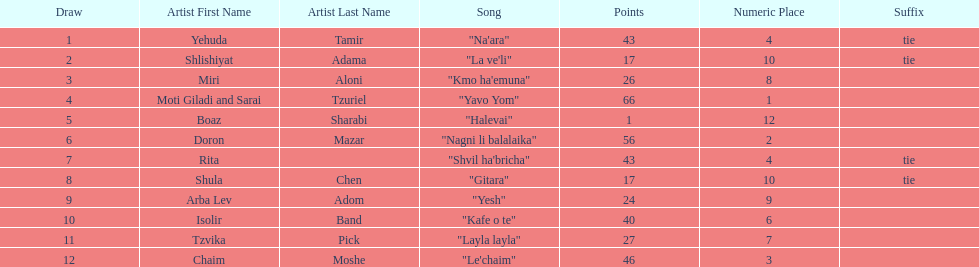What song earned the most points? "Yavo Yom". Could you parse the entire table as a dict? {'header': ['Draw', 'Artist First Name', 'Artist Last Name', 'Song', 'Points', 'Numeric Place', 'Suffix'], 'rows': [['1', 'Yehuda', 'Tamir', '"Na\'ara"', '43', '4', 'tie'], ['2', 'Shlishiyat', 'Adama', '"La ve\'li"', '17', '10', 'tie'], ['3', 'Miri', 'Aloni', '"Kmo ha\'emuna"', '26', '8', ''], ['4', 'Moti Giladi and Sarai', 'Tzuriel', '"Yavo Yom"', '66', '1', ''], ['5', 'Boaz', 'Sharabi', '"Halevai"', '1', '12', ''], ['6', 'Doron', 'Mazar', '"Nagni li balalaika"', '56', '2', ''], ['7', 'Rita', '', '"Shvil ha\'bricha"', '43', '4', 'tie'], ['8', 'Shula', 'Chen', '"Gitara"', '17', '10', 'tie'], ['9', 'Arba Lev', 'Adom', '"Yesh"', '24', '9', ''], ['10', 'Isolir', 'Band', '"Kafe o te"', '40', '6', ''], ['11', 'Tzvika', 'Pick', '"Layla layla"', '27', '7', ''], ['12', 'Chaim', 'Moshe', '"Le\'chaim"', '46', '3', '']]} 